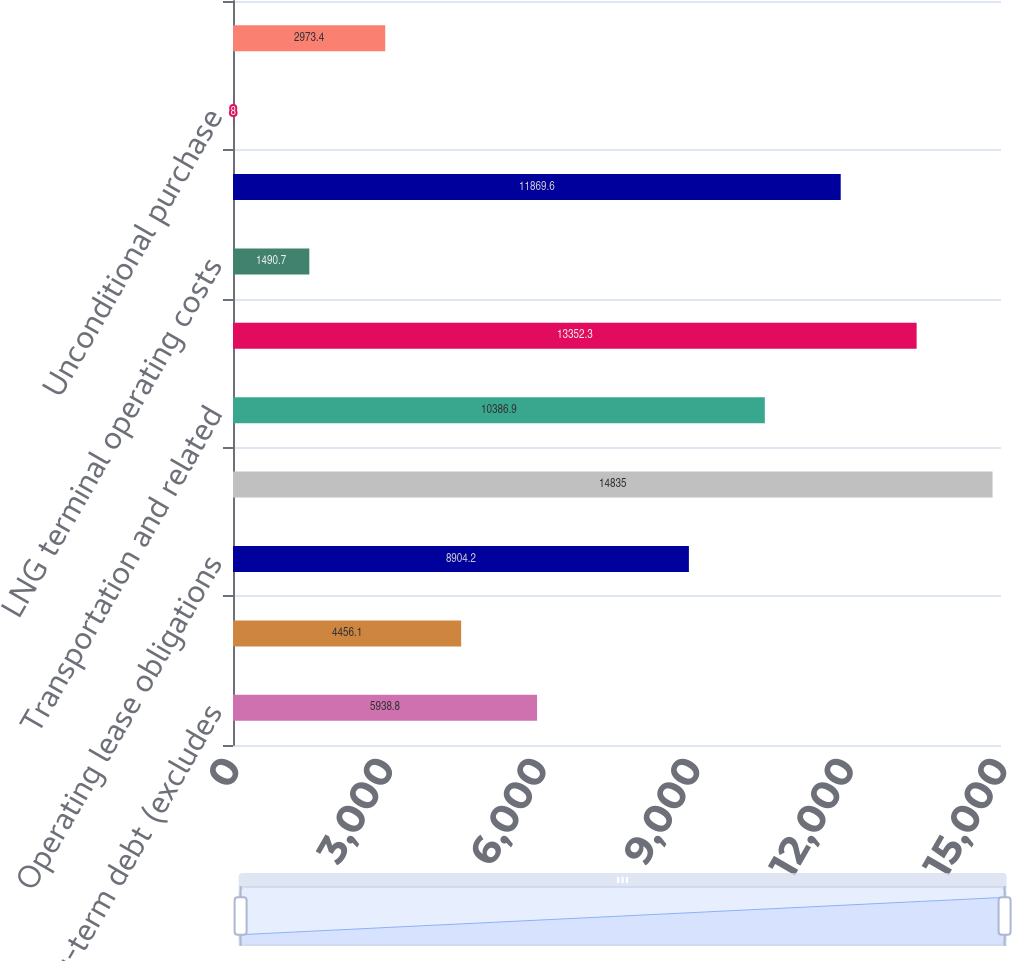Convert chart. <chart><loc_0><loc_0><loc_500><loc_500><bar_chart><fcel>Long-term debt (excludes<fcel>Capital lease obligations (a)<fcel>Operating lease obligations<fcel>Crude oil feedstock refined<fcel>Transportation and related<fcel>Contracts to acquire property<fcel>LNG terminal operating costs<fcel>Service and materials<fcel>Unconditional purchase<fcel>Commitments for oil and gas<nl><fcel>5938.8<fcel>4456.1<fcel>8904.2<fcel>14835<fcel>10386.9<fcel>13352.3<fcel>1490.7<fcel>11869.6<fcel>8<fcel>2973.4<nl></chart> 